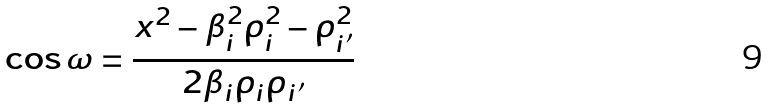Convert formula to latex. <formula><loc_0><loc_0><loc_500><loc_500>\cos \omega = \frac { x ^ { 2 } - \beta _ { i } ^ { 2 } \rho _ { i } ^ { 2 } - \rho _ { i ^ { \prime } } ^ { 2 } } { 2 \beta _ { i } \rho _ { i } \rho _ { i ^ { \prime } } }</formula> 